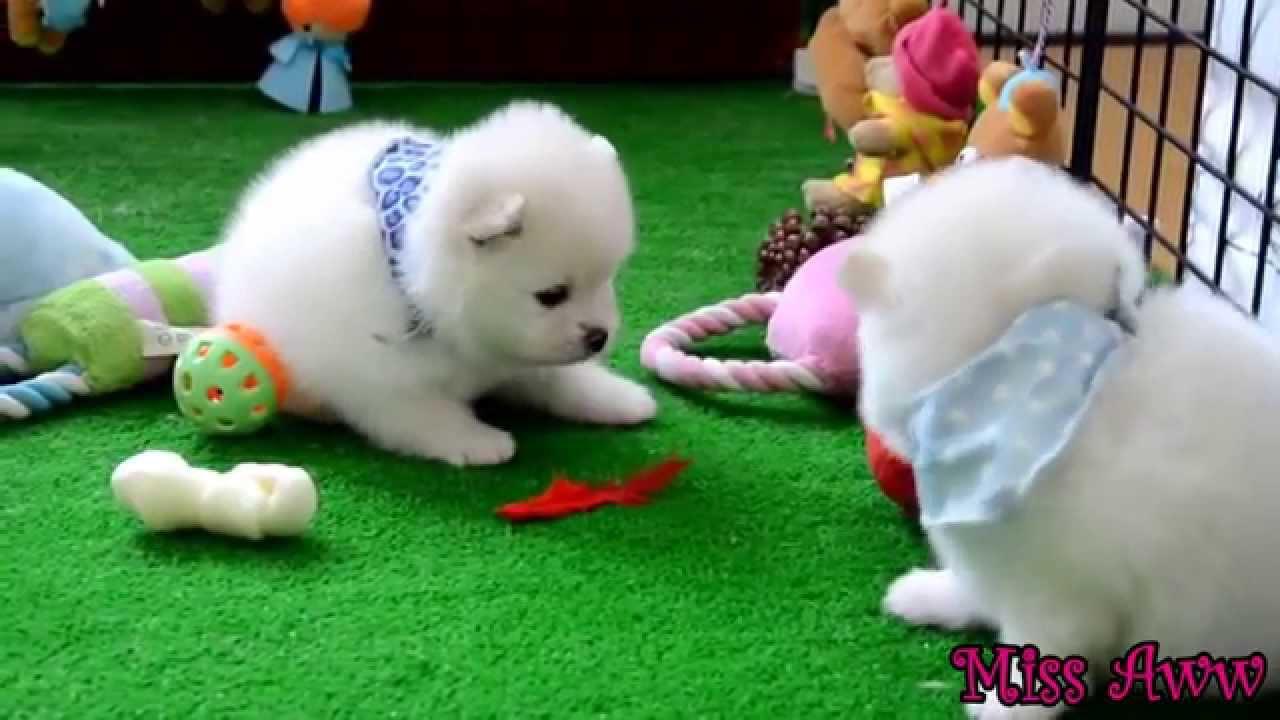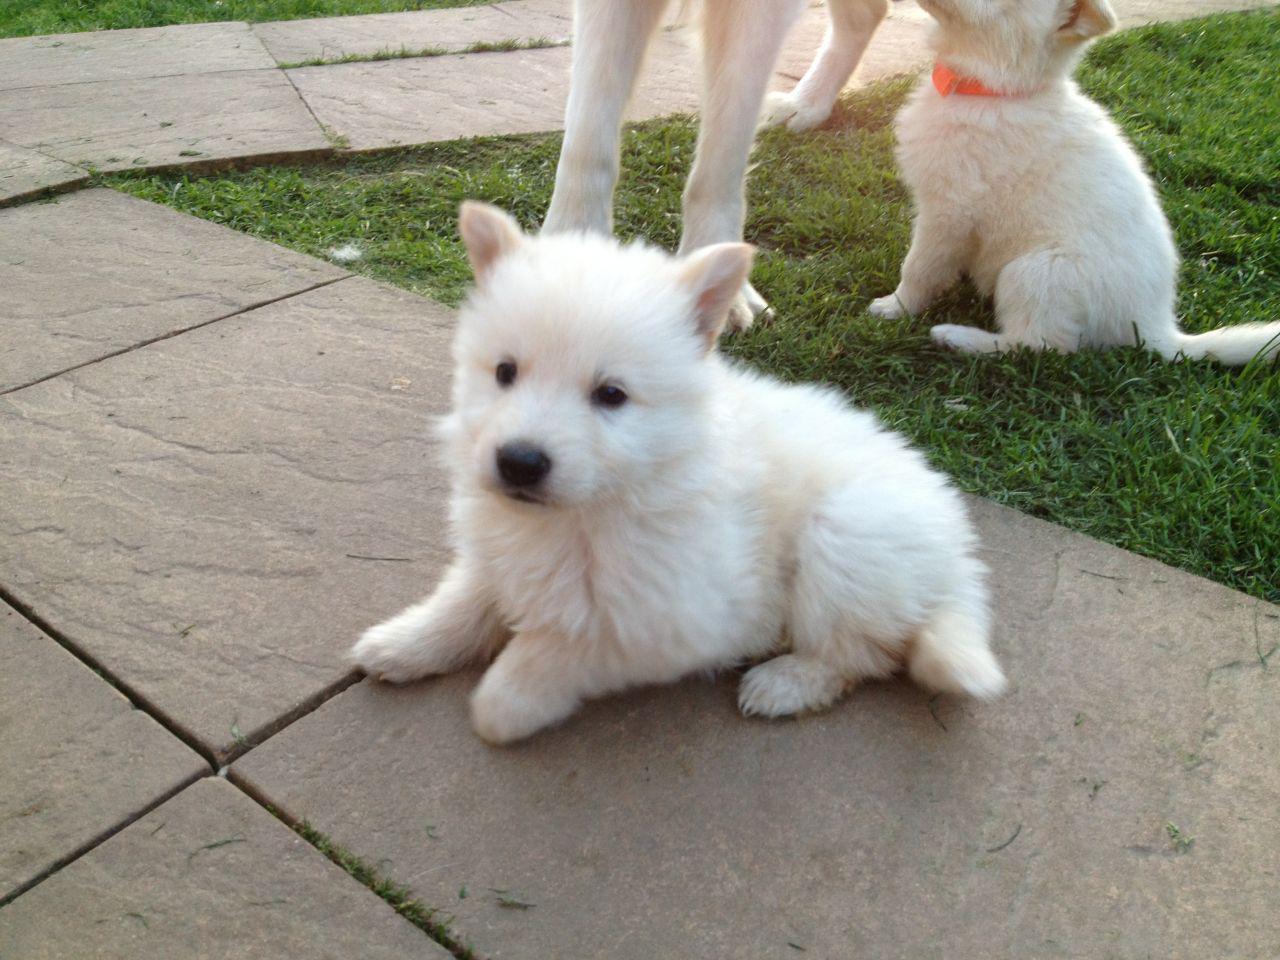The first image is the image on the left, the second image is the image on the right. Considering the images on both sides, is "At least one dog has its mouth open." valid? Answer yes or no. No. The first image is the image on the left, the second image is the image on the right. Analyze the images presented: Is the assertion "A total of three white dogs are shown, and the two dogs in one image are lookalikes, but do not closely resemble the lone dog in the other image." valid? Answer yes or no. No. 